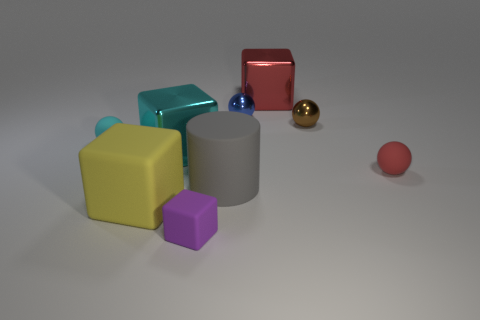Subtract all small red rubber balls. How many balls are left? 3 Add 1 tiny red blocks. How many objects exist? 10 Subtract all brown spheres. How many spheres are left? 3 Subtract all cubes. How many objects are left? 5 Subtract 2 balls. How many balls are left? 2 Subtract all yellow cylinders. Subtract all cyan cubes. How many cylinders are left? 1 Subtract all red metal balls. Subtract all purple things. How many objects are left? 8 Add 3 large gray cylinders. How many large gray cylinders are left? 4 Add 4 red things. How many red things exist? 6 Subtract 0 blue cubes. How many objects are left? 9 